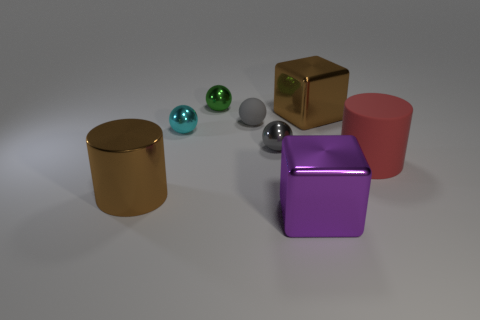Subtract all blue cylinders. How many gray balls are left? 2 Subtract all green balls. How many balls are left? 3 Subtract all green balls. How many balls are left? 3 Add 1 brown shiny cylinders. How many objects exist? 9 Subtract all brown spheres. Subtract all gray cylinders. How many spheres are left? 4 Subtract all blocks. How many objects are left? 6 Subtract all tiny things. Subtract all gray rubber balls. How many objects are left? 3 Add 1 gray rubber spheres. How many gray rubber spheres are left? 2 Add 2 large metal things. How many large metal things exist? 5 Subtract 0 blue blocks. How many objects are left? 8 